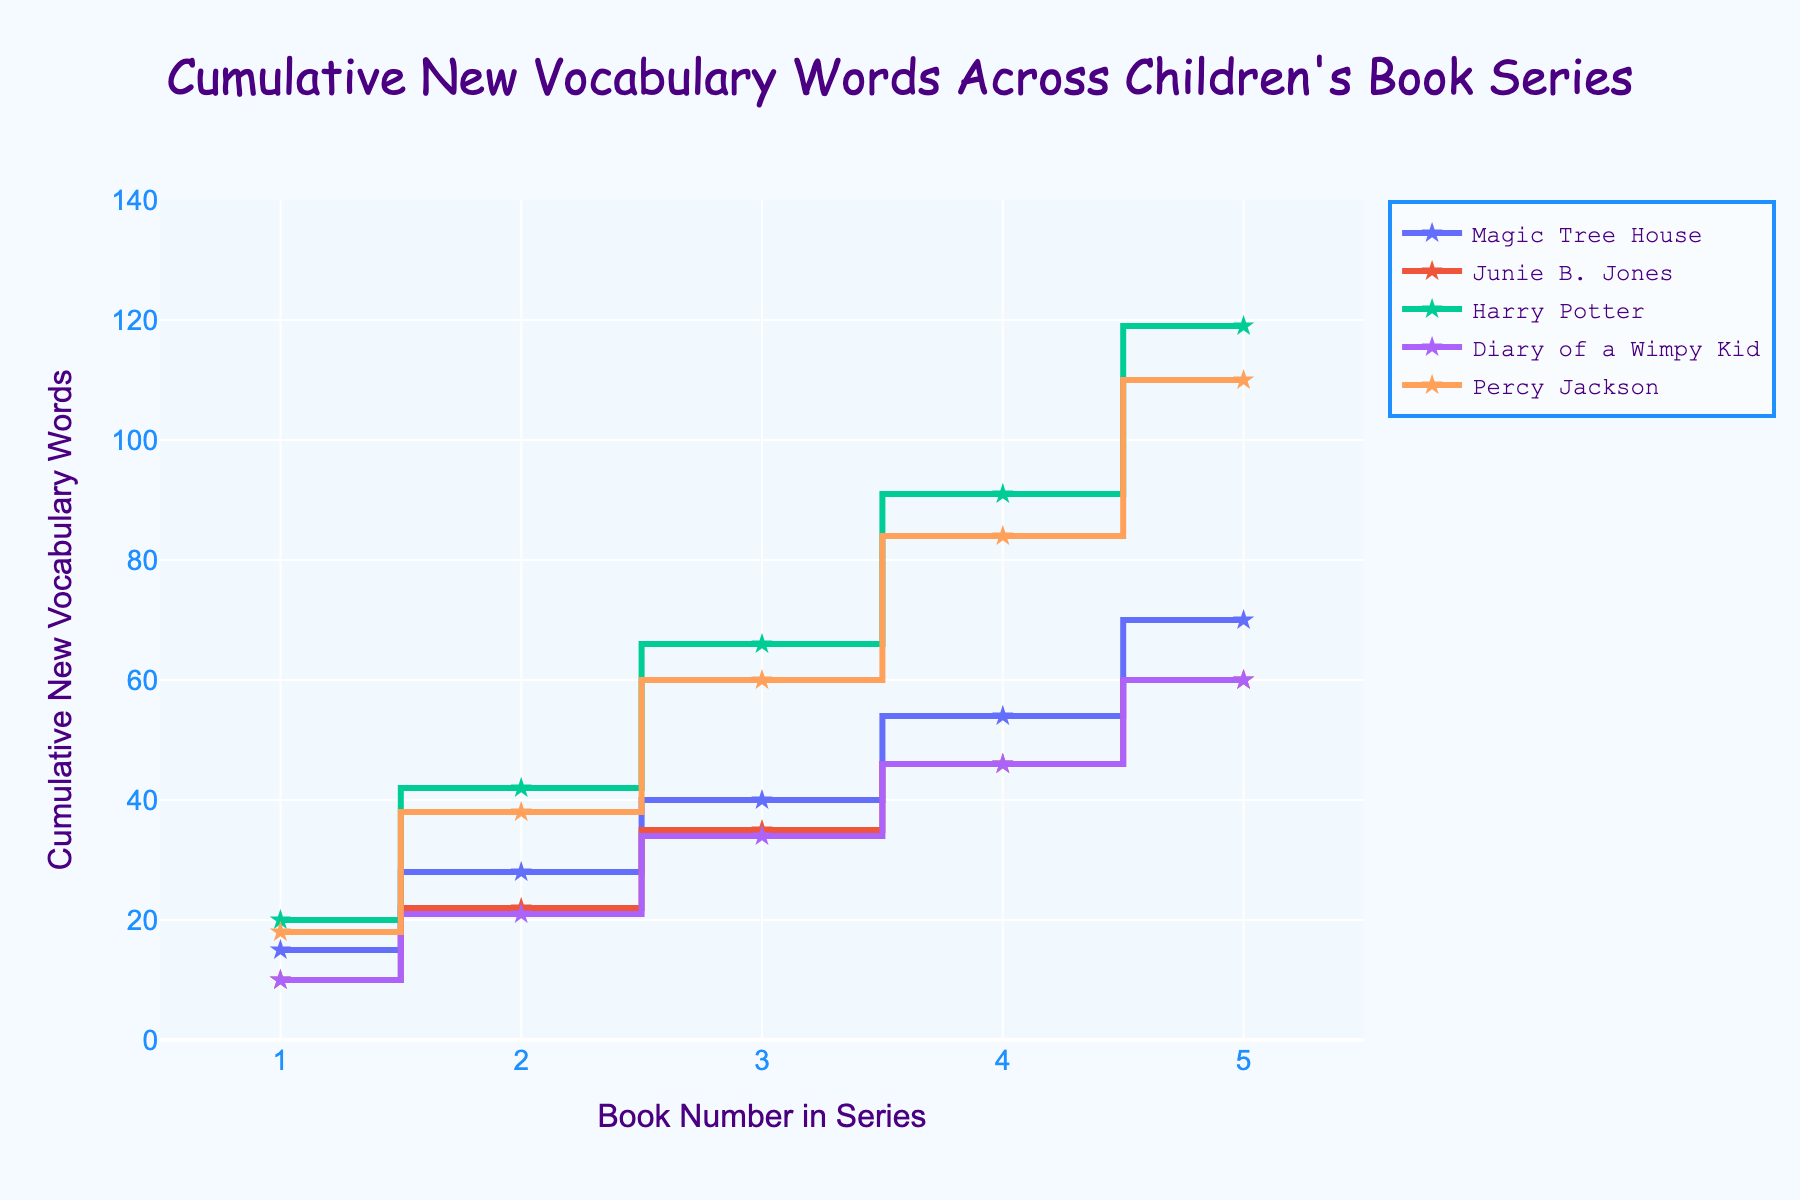What's the title of the plot? The title of the plot is located at the top and reads 'Cumulative New Vocabulary Words Across Children's Book Series'.
Answer: 'Cumulative New Vocabulary Words Across Children's Book Series' How many book series are displayed in the plot? The legend lists all the series, and there are five markers each with a different label.
Answer: 5 Which book series introduces the highest number of new vocabulary words in the fifth book? By observing the end points of the stair lines, 'Harry Potter' has the highest endpoint at the fifth book.
Answer: Harry Potter How many cumulative new vocabulary words does 'Harry Potter' introduce by the third book? Follow the 'Harry Potter' stair step line to the third book on the x-axis, which corresponds to around 66 cumulative vocabulary words (20+22+24).
Answer: 66 What is the color used for the 'Magic Tree House' series in the plot? The color of the line and markers for the 'Magic Tree House' series can be determined by looking at the legend and the plot.
Answer: Green (or whatever color is used in the figure) Compare the increase in new vocabulary words between book 2 and book 3 for 'Junie B. Jones' and 'Diary of a Wimpy Kid'. Which one has a higher increase? For 'Junie B. Jones', the increase from book 2 to book 3 is 1 word (13-12), and for 'Diary of a Wimpy Kid', it’s 2 words (13-11).
Answer: Diary of a Wimpy Kid What is the cumulative number of new vocabulary words introduced in 'Magic Tree House' by book 5? Sum the values of 'Magic Tree House' up to book 5: 15 + 13 + 12 + 14 + 16 = 70.
Answer: 70 Which series shows a consistent increase in new vocabulary words with each book? Following the lines in the plot, 'Harry Potter' and 'Percy Jackson' show a consistent step-wise increase without dips.
Answer: Harry Potter and Percy Jackson By how many words does the 'Harry Potter' series surpass the 'Magic Tree House' series in cumulative vocabulary introduced by book 5? Compare 'Harry Potter' by book 5 (20+22+24+25+28=119) and 'Magic Tree House' (15+13+12+14+16=70); the difference is 119 - 70.
Answer: 49 Which series shows the smallest climb in cumulative vocabulary between the first and the second book? Look at the difference in height from book 1 to book 2 for each series; 'Junie B. Jones' has the smallest climb of just 2 words (12-10).
Answer: Junie B. Jones 